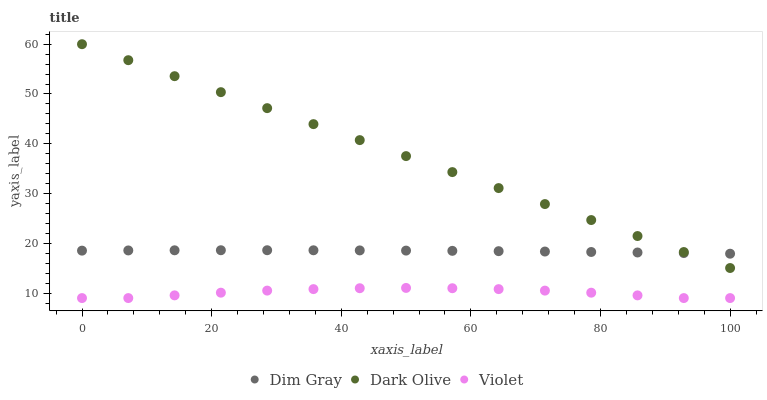Does Violet have the minimum area under the curve?
Answer yes or no. Yes. Does Dark Olive have the maximum area under the curve?
Answer yes or no. Yes. Does Dim Gray have the minimum area under the curve?
Answer yes or no. No. Does Dim Gray have the maximum area under the curve?
Answer yes or no. No. Is Dark Olive the smoothest?
Answer yes or no. Yes. Is Violet the roughest?
Answer yes or no. Yes. Is Dim Gray the smoothest?
Answer yes or no. No. Is Dim Gray the roughest?
Answer yes or no. No. Does Violet have the lowest value?
Answer yes or no. Yes. Does Dim Gray have the lowest value?
Answer yes or no. No. Does Dark Olive have the highest value?
Answer yes or no. Yes. Does Dim Gray have the highest value?
Answer yes or no. No. Is Violet less than Dark Olive?
Answer yes or no. Yes. Is Dark Olive greater than Violet?
Answer yes or no. Yes. Does Dark Olive intersect Dim Gray?
Answer yes or no. Yes. Is Dark Olive less than Dim Gray?
Answer yes or no. No. Is Dark Olive greater than Dim Gray?
Answer yes or no. No. Does Violet intersect Dark Olive?
Answer yes or no. No. 